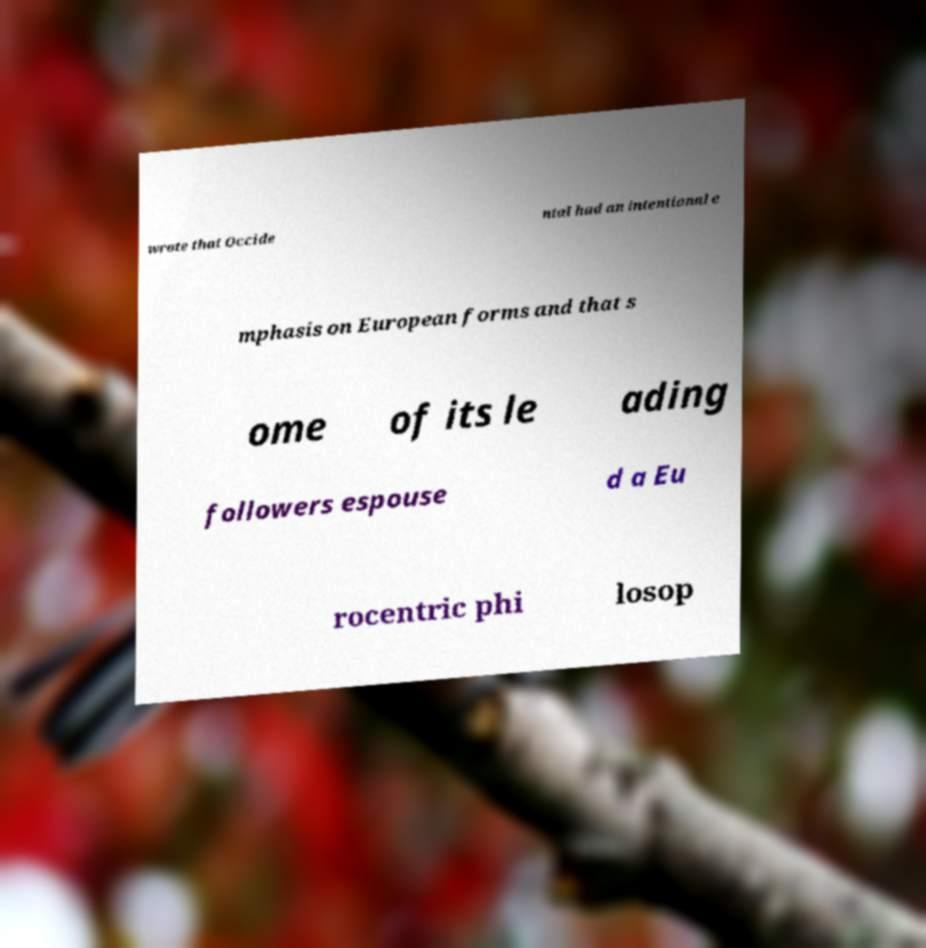I need the written content from this picture converted into text. Can you do that? wrote that Occide ntal had an intentional e mphasis on European forms and that s ome of its le ading followers espouse d a Eu rocentric phi losop 